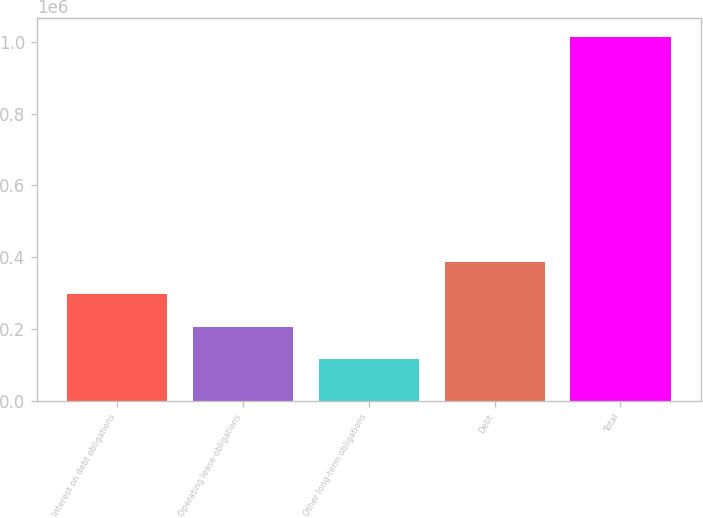<chart> <loc_0><loc_0><loc_500><loc_500><bar_chart><fcel>Interest on debt obligations<fcel>Operating lease obligations<fcel>Other long-term obligations<fcel>Debt<fcel>Total<nl><fcel>296736<fcel>206991<fcel>117246<fcel>386481<fcel>1.0147e+06<nl></chart> 